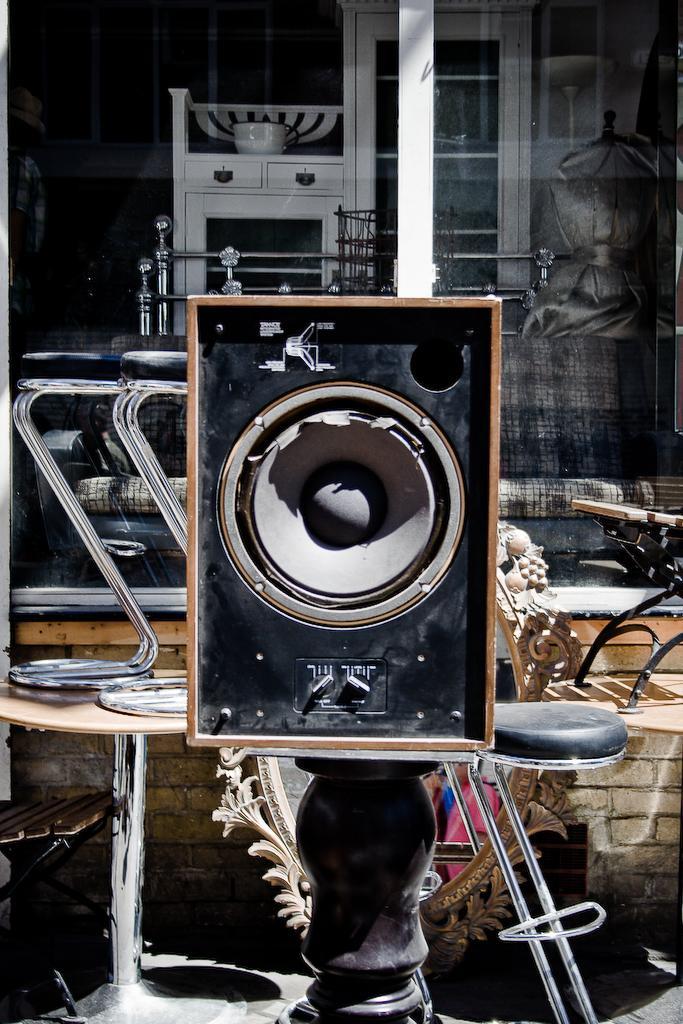Can you describe this image briefly? In this image there are tables, speaker, glass window, cupboard, mirror and objects. 